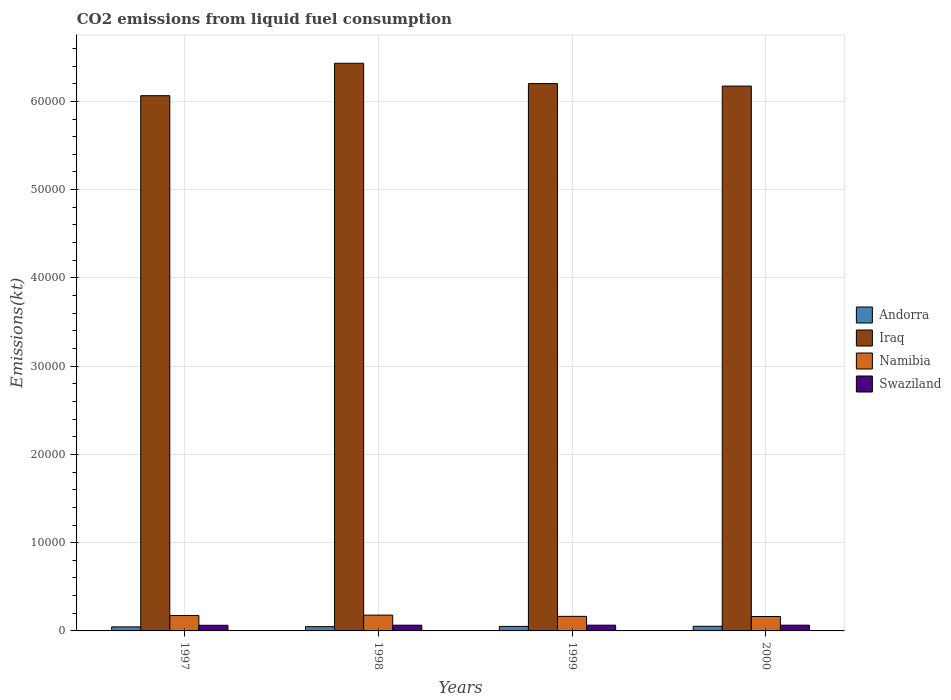How many groups of bars are there?
Make the answer very short. 4. Are the number of bars per tick equal to the number of legend labels?
Ensure brevity in your answer.  Yes. How many bars are there on the 1st tick from the left?
Make the answer very short. 4. How many bars are there on the 1st tick from the right?
Your answer should be compact. 4. What is the label of the 2nd group of bars from the left?
Offer a very short reply. 1998. What is the amount of CO2 emitted in Swaziland in 1998?
Your answer should be very brief. 649.06. Across all years, what is the maximum amount of CO2 emitted in Iraq?
Offer a very short reply. 6.43e+04. Across all years, what is the minimum amount of CO2 emitted in Namibia?
Your response must be concise. 1631.82. In which year was the amount of CO2 emitted in Andorra maximum?
Your response must be concise. 2000. What is the total amount of CO2 emitted in Swaziland in the graph?
Provide a short and direct response. 2592.57. What is the difference between the amount of CO2 emitted in Namibia in 1997 and that in 1999?
Your response must be concise. 91.67. What is the difference between the amount of CO2 emitted in Namibia in 2000 and the amount of CO2 emitted in Swaziland in 1999?
Your answer should be very brief. 979.09. What is the average amount of CO2 emitted in Swaziland per year?
Give a very brief answer. 648.14. In the year 1997, what is the difference between the amount of CO2 emitted in Namibia and amount of CO2 emitted in Andorra?
Keep it short and to the point. 1283.45. In how many years, is the amount of CO2 emitted in Swaziland greater than 12000 kt?
Ensure brevity in your answer.  0. What is the ratio of the amount of CO2 emitted in Andorra in 1999 to that in 2000?
Offer a very short reply. 0.98. What is the difference between the highest and the second highest amount of CO2 emitted in Namibia?
Make the answer very short. 47.67. What is the difference between the highest and the lowest amount of CO2 emitted in Swaziland?
Give a very brief answer. 14.67. Is the sum of the amount of CO2 emitted in Swaziland in 1997 and 2000 greater than the maximum amount of CO2 emitted in Iraq across all years?
Offer a terse response. No. What does the 1st bar from the left in 1998 represents?
Your response must be concise. Andorra. What does the 3rd bar from the right in 1999 represents?
Provide a succinct answer. Iraq. Does the graph contain any zero values?
Your answer should be compact. No. Does the graph contain grids?
Make the answer very short. Yes. Where does the legend appear in the graph?
Offer a terse response. Center right. How many legend labels are there?
Keep it short and to the point. 4. What is the title of the graph?
Offer a terse response. CO2 emissions from liquid fuel consumption. Does "Greece" appear as one of the legend labels in the graph?
Provide a short and direct response. No. What is the label or title of the Y-axis?
Your answer should be very brief. Emissions(kt). What is the Emissions(kt) in Andorra in 1997?
Provide a succinct answer. 458.38. What is the Emissions(kt) in Iraq in 1997?
Provide a short and direct response. 6.06e+04. What is the Emissions(kt) of Namibia in 1997?
Ensure brevity in your answer.  1741.83. What is the Emissions(kt) in Swaziland in 1997?
Offer a very short reply. 638.06. What is the Emissions(kt) in Andorra in 1998?
Your answer should be compact. 484.04. What is the Emissions(kt) of Iraq in 1998?
Ensure brevity in your answer.  6.43e+04. What is the Emissions(kt) in Namibia in 1998?
Offer a terse response. 1789.5. What is the Emissions(kt) in Swaziland in 1998?
Make the answer very short. 649.06. What is the Emissions(kt) in Andorra in 1999?
Offer a very short reply. 513.38. What is the Emissions(kt) of Iraq in 1999?
Your answer should be compact. 6.20e+04. What is the Emissions(kt) in Namibia in 1999?
Provide a short and direct response. 1650.15. What is the Emissions(kt) in Swaziland in 1999?
Provide a succinct answer. 652.73. What is the Emissions(kt) of Andorra in 2000?
Offer a terse response. 524.38. What is the Emissions(kt) in Iraq in 2000?
Keep it short and to the point. 6.17e+04. What is the Emissions(kt) in Namibia in 2000?
Offer a terse response. 1631.82. What is the Emissions(kt) in Swaziland in 2000?
Ensure brevity in your answer.  652.73. Across all years, what is the maximum Emissions(kt) in Andorra?
Your answer should be very brief. 524.38. Across all years, what is the maximum Emissions(kt) of Iraq?
Your answer should be compact. 6.43e+04. Across all years, what is the maximum Emissions(kt) in Namibia?
Ensure brevity in your answer.  1789.5. Across all years, what is the maximum Emissions(kt) in Swaziland?
Provide a short and direct response. 652.73. Across all years, what is the minimum Emissions(kt) in Andorra?
Keep it short and to the point. 458.38. Across all years, what is the minimum Emissions(kt) in Iraq?
Your response must be concise. 6.06e+04. Across all years, what is the minimum Emissions(kt) of Namibia?
Make the answer very short. 1631.82. Across all years, what is the minimum Emissions(kt) in Swaziland?
Your answer should be compact. 638.06. What is the total Emissions(kt) of Andorra in the graph?
Your response must be concise. 1980.18. What is the total Emissions(kt) in Iraq in the graph?
Your answer should be very brief. 2.49e+05. What is the total Emissions(kt) in Namibia in the graph?
Your answer should be compact. 6813.29. What is the total Emissions(kt) in Swaziland in the graph?
Offer a very short reply. 2592.57. What is the difference between the Emissions(kt) of Andorra in 1997 and that in 1998?
Your answer should be compact. -25.67. What is the difference between the Emissions(kt) in Iraq in 1997 and that in 1998?
Offer a very short reply. -3674.33. What is the difference between the Emissions(kt) in Namibia in 1997 and that in 1998?
Keep it short and to the point. -47.67. What is the difference between the Emissions(kt) of Swaziland in 1997 and that in 1998?
Make the answer very short. -11. What is the difference between the Emissions(kt) in Andorra in 1997 and that in 1999?
Provide a succinct answer. -55.01. What is the difference between the Emissions(kt) of Iraq in 1997 and that in 1999?
Keep it short and to the point. -1371.46. What is the difference between the Emissions(kt) of Namibia in 1997 and that in 1999?
Offer a terse response. 91.67. What is the difference between the Emissions(kt) in Swaziland in 1997 and that in 1999?
Give a very brief answer. -14.67. What is the difference between the Emissions(kt) in Andorra in 1997 and that in 2000?
Give a very brief answer. -66.01. What is the difference between the Emissions(kt) of Iraq in 1997 and that in 2000?
Your answer should be compact. -1089.1. What is the difference between the Emissions(kt) of Namibia in 1997 and that in 2000?
Keep it short and to the point. 110.01. What is the difference between the Emissions(kt) of Swaziland in 1997 and that in 2000?
Your answer should be compact. -14.67. What is the difference between the Emissions(kt) in Andorra in 1998 and that in 1999?
Your response must be concise. -29.34. What is the difference between the Emissions(kt) of Iraq in 1998 and that in 1999?
Your answer should be very brief. 2302.88. What is the difference between the Emissions(kt) in Namibia in 1998 and that in 1999?
Ensure brevity in your answer.  139.35. What is the difference between the Emissions(kt) in Swaziland in 1998 and that in 1999?
Make the answer very short. -3.67. What is the difference between the Emissions(kt) of Andorra in 1998 and that in 2000?
Give a very brief answer. -40.34. What is the difference between the Emissions(kt) in Iraq in 1998 and that in 2000?
Give a very brief answer. 2585.24. What is the difference between the Emissions(kt) in Namibia in 1998 and that in 2000?
Your answer should be very brief. 157.68. What is the difference between the Emissions(kt) of Swaziland in 1998 and that in 2000?
Ensure brevity in your answer.  -3.67. What is the difference between the Emissions(kt) of Andorra in 1999 and that in 2000?
Your answer should be compact. -11. What is the difference between the Emissions(kt) of Iraq in 1999 and that in 2000?
Ensure brevity in your answer.  282.36. What is the difference between the Emissions(kt) in Namibia in 1999 and that in 2000?
Keep it short and to the point. 18.34. What is the difference between the Emissions(kt) of Andorra in 1997 and the Emissions(kt) of Iraq in 1998?
Your answer should be very brief. -6.39e+04. What is the difference between the Emissions(kt) in Andorra in 1997 and the Emissions(kt) in Namibia in 1998?
Make the answer very short. -1331.12. What is the difference between the Emissions(kt) in Andorra in 1997 and the Emissions(kt) in Swaziland in 1998?
Offer a terse response. -190.68. What is the difference between the Emissions(kt) of Iraq in 1997 and the Emissions(kt) of Namibia in 1998?
Give a very brief answer. 5.89e+04. What is the difference between the Emissions(kt) in Iraq in 1997 and the Emissions(kt) in Swaziland in 1998?
Your response must be concise. 6.00e+04. What is the difference between the Emissions(kt) in Namibia in 1997 and the Emissions(kt) in Swaziland in 1998?
Give a very brief answer. 1092.77. What is the difference between the Emissions(kt) of Andorra in 1997 and the Emissions(kt) of Iraq in 1999?
Offer a very short reply. -6.16e+04. What is the difference between the Emissions(kt) in Andorra in 1997 and the Emissions(kt) in Namibia in 1999?
Provide a short and direct response. -1191.78. What is the difference between the Emissions(kt) of Andorra in 1997 and the Emissions(kt) of Swaziland in 1999?
Ensure brevity in your answer.  -194.35. What is the difference between the Emissions(kt) in Iraq in 1997 and the Emissions(kt) in Namibia in 1999?
Your response must be concise. 5.90e+04. What is the difference between the Emissions(kt) of Iraq in 1997 and the Emissions(kt) of Swaziland in 1999?
Provide a succinct answer. 6.00e+04. What is the difference between the Emissions(kt) in Namibia in 1997 and the Emissions(kt) in Swaziland in 1999?
Your answer should be very brief. 1089.1. What is the difference between the Emissions(kt) in Andorra in 1997 and the Emissions(kt) in Iraq in 2000?
Provide a short and direct response. -6.13e+04. What is the difference between the Emissions(kt) of Andorra in 1997 and the Emissions(kt) of Namibia in 2000?
Your answer should be compact. -1173.44. What is the difference between the Emissions(kt) in Andorra in 1997 and the Emissions(kt) in Swaziland in 2000?
Your answer should be very brief. -194.35. What is the difference between the Emissions(kt) of Iraq in 1997 and the Emissions(kt) of Namibia in 2000?
Your answer should be compact. 5.90e+04. What is the difference between the Emissions(kt) of Iraq in 1997 and the Emissions(kt) of Swaziland in 2000?
Make the answer very short. 6.00e+04. What is the difference between the Emissions(kt) in Namibia in 1997 and the Emissions(kt) in Swaziland in 2000?
Ensure brevity in your answer.  1089.1. What is the difference between the Emissions(kt) of Andorra in 1998 and the Emissions(kt) of Iraq in 1999?
Keep it short and to the point. -6.15e+04. What is the difference between the Emissions(kt) in Andorra in 1998 and the Emissions(kt) in Namibia in 1999?
Your answer should be very brief. -1166.11. What is the difference between the Emissions(kt) of Andorra in 1998 and the Emissions(kt) of Swaziland in 1999?
Provide a succinct answer. -168.68. What is the difference between the Emissions(kt) in Iraq in 1998 and the Emissions(kt) in Namibia in 1999?
Provide a succinct answer. 6.27e+04. What is the difference between the Emissions(kt) in Iraq in 1998 and the Emissions(kt) in Swaziland in 1999?
Give a very brief answer. 6.37e+04. What is the difference between the Emissions(kt) of Namibia in 1998 and the Emissions(kt) of Swaziland in 1999?
Your answer should be compact. 1136.77. What is the difference between the Emissions(kt) in Andorra in 1998 and the Emissions(kt) in Iraq in 2000?
Provide a succinct answer. -6.12e+04. What is the difference between the Emissions(kt) in Andorra in 1998 and the Emissions(kt) in Namibia in 2000?
Provide a short and direct response. -1147.77. What is the difference between the Emissions(kt) of Andorra in 1998 and the Emissions(kt) of Swaziland in 2000?
Keep it short and to the point. -168.68. What is the difference between the Emissions(kt) of Iraq in 1998 and the Emissions(kt) of Namibia in 2000?
Provide a succinct answer. 6.27e+04. What is the difference between the Emissions(kt) of Iraq in 1998 and the Emissions(kt) of Swaziland in 2000?
Offer a terse response. 6.37e+04. What is the difference between the Emissions(kt) in Namibia in 1998 and the Emissions(kt) in Swaziland in 2000?
Offer a terse response. 1136.77. What is the difference between the Emissions(kt) of Andorra in 1999 and the Emissions(kt) of Iraq in 2000?
Provide a short and direct response. -6.12e+04. What is the difference between the Emissions(kt) in Andorra in 1999 and the Emissions(kt) in Namibia in 2000?
Provide a short and direct response. -1118.43. What is the difference between the Emissions(kt) of Andorra in 1999 and the Emissions(kt) of Swaziland in 2000?
Give a very brief answer. -139.35. What is the difference between the Emissions(kt) in Iraq in 1999 and the Emissions(kt) in Namibia in 2000?
Provide a succinct answer. 6.04e+04. What is the difference between the Emissions(kt) in Iraq in 1999 and the Emissions(kt) in Swaziland in 2000?
Provide a short and direct response. 6.14e+04. What is the difference between the Emissions(kt) in Namibia in 1999 and the Emissions(kt) in Swaziland in 2000?
Provide a short and direct response. 997.42. What is the average Emissions(kt) of Andorra per year?
Give a very brief answer. 495.05. What is the average Emissions(kt) of Iraq per year?
Provide a succinct answer. 6.22e+04. What is the average Emissions(kt) in Namibia per year?
Provide a short and direct response. 1703.32. What is the average Emissions(kt) of Swaziland per year?
Offer a terse response. 648.14. In the year 1997, what is the difference between the Emissions(kt) of Andorra and Emissions(kt) of Iraq?
Keep it short and to the point. -6.02e+04. In the year 1997, what is the difference between the Emissions(kt) in Andorra and Emissions(kt) in Namibia?
Your response must be concise. -1283.45. In the year 1997, what is the difference between the Emissions(kt) in Andorra and Emissions(kt) in Swaziland?
Offer a very short reply. -179.68. In the year 1997, what is the difference between the Emissions(kt) of Iraq and Emissions(kt) of Namibia?
Ensure brevity in your answer.  5.89e+04. In the year 1997, what is the difference between the Emissions(kt) of Iraq and Emissions(kt) of Swaziland?
Your answer should be compact. 6.00e+04. In the year 1997, what is the difference between the Emissions(kt) of Namibia and Emissions(kt) of Swaziland?
Your response must be concise. 1103.77. In the year 1998, what is the difference between the Emissions(kt) of Andorra and Emissions(kt) of Iraq?
Your answer should be very brief. -6.38e+04. In the year 1998, what is the difference between the Emissions(kt) of Andorra and Emissions(kt) of Namibia?
Make the answer very short. -1305.45. In the year 1998, what is the difference between the Emissions(kt) in Andorra and Emissions(kt) in Swaziland?
Keep it short and to the point. -165.01. In the year 1998, what is the difference between the Emissions(kt) of Iraq and Emissions(kt) of Namibia?
Your answer should be very brief. 6.25e+04. In the year 1998, what is the difference between the Emissions(kt) in Iraq and Emissions(kt) in Swaziland?
Your response must be concise. 6.37e+04. In the year 1998, what is the difference between the Emissions(kt) of Namibia and Emissions(kt) of Swaziland?
Provide a short and direct response. 1140.44. In the year 1999, what is the difference between the Emissions(kt) of Andorra and Emissions(kt) of Iraq?
Keep it short and to the point. -6.15e+04. In the year 1999, what is the difference between the Emissions(kt) in Andorra and Emissions(kt) in Namibia?
Ensure brevity in your answer.  -1136.77. In the year 1999, what is the difference between the Emissions(kt) of Andorra and Emissions(kt) of Swaziland?
Offer a very short reply. -139.35. In the year 1999, what is the difference between the Emissions(kt) of Iraq and Emissions(kt) of Namibia?
Provide a short and direct response. 6.04e+04. In the year 1999, what is the difference between the Emissions(kt) in Iraq and Emissions(kt) in Swaziland?
Keep it short and to the point. 6.14e+04. In the year 1999, what is the difference between the Emissions(kt) of Namibia and Emissions(kt) of Swaziland?
Offer a very short reply. 997.42. In the year 2000, what is the difference between the Emissions(kt) in Andorra and Emissions(kt) in Iraq?
Keep it short and to the point. -6.12e+04. In the year 2000, what is the difference between the Emissions(kt) in Andorra and Emissions(kt) in Namibia?
Your response must be concise. -1107.43. In the year 2000, what is the difference between the Emissions(kt) in Andorra and Emissions(kt) in Swaziland?
Provide a short and direct response. -128.34. In the year 2000, what is the difference between the Emissions(kt) in Iraq and Emissions(kt) in Namibia?
Keep it short and to the point. 6.01e+04. In the year 2000, what is the difference between the Emissions(kt) in Iraq and Emissions(kt) in Swaziland?
Offer a very short reply. 6.11e+04. In the year 2000, what is the difference between the Emissions(kt) in Namibia and Emissions(kt) in Swaziland?
Keep it short and to the point. 979.09. What is the ratio of the Emissions(kt) in Andorra in 1997 to that in 1998?
Offer a terse response. 0.95. What is the ratio of the Emissions(kt) in Iraq in 1997 to that in 1998?
Offer a terse response. 0.94. What is the ratio of the Emissions(kt) of Namibia in 1997 to that in 1998?
Offer a very short reply. 0.97. What is the ratio of the Emissions(kt) in Swaziland in 1997 to that in 1998?
Your response must be concise. 0.98. What is the ratio of the Emissions(kt) of Andorra in 1997 to that in 1999?
Ensure brevity in your answer.  0.89. What is the ratio of the Emissions(kt) of Iraq in 1997 to that in 1999?
Ensure brevity in your answer.  0.98. What is the ratio of the Emissions(kt) of Namibia in 1997 to that in 1999?
Give a very brief answer. 1.06. What is the ratio of the Emissions(kt) in Swaziland in 1997 to that in 1999?
Your answer should be compact. 0.98. What is the ratio of the Emissions(kt) in Andorra in 1997 to that in 2000?
Offer a very short reply. 0.87. What is the ratio of the Emissions(kt) of Iraq in 1997 to that in 2000?
Your answer should be very brief. 0.98. What is the ratio of the Emissions(kt) of Namibia in 1997 to that in 2000?
Make the answer very short. 1.07. What is the ratio of the Emissions(kt) in Swaziland in 1997 to that in 2000?
Offer a very short reply. 0.98. What is the ratio of the Emissions(kt) in Andorra in 1998 to that in 1999?
Ensure brevity in your answer.  0.94. What is the ratio of the Emissions(kt) in Iraq in 1998 to that in 1999?
Your answer should be compact. 1.04. What is the ratio of the Emissions(kt) of Namibia in 1998 to that in 1999?
Your answer should be compact. 1.08. What is the ratio of the Emissions(kt) of Swaziland in 1998 to that in 1999?
Offer a very short reply. 0.99. What is the ratio of the Emissions(kt) of Iraq in 1998 to that in 2000?
Ensure brevity in your answer.  1.04. What is the ratio of the Emissions(kt) of Namibia in 1998 to that in 2000?
Provide a succinct answer. 1.1. What is the ratio of the Emissions(kt) of Swaziland in 1998 to that in 2000?
Keep it short and to the point. 0.99. What is the ratio of the Emissions(kt) in Namibia in 1999 to that in 2000?
Your answer should be very brief. 1.01. What is the difference between the highest and the second highest Emissions(kt) of Andorra?
Offer a terse response. 11. What is the difference between the highest and the second highest Emissions(kt) of Iraq?
Give a very brief answer. 2302.88. What is the difference between the highest and the second highest Emissions(kt) in Namibia?
Provide a short and direct response. 47.67. What is the difference between the highest and the second highest Emissions(kt) in Swaziland?
Offer a terse response. 0. What is the difference between the highest and the lowest Emissions(kt) in Andorra?
Provide a short and direct response. 66.01. What is the difference between the highest and the lowest Emissions(kt) in Iraq?
Offer a very short reply. 3674.33. What is the difference between the highest and the lowest Emissions(kt) in Namibia?
Ensure brevity in your answer.  157.68. What is the difference between the highest and the lowest Emissions(kt) of Swaziland?
Your answer should be very brief. 14.67. 